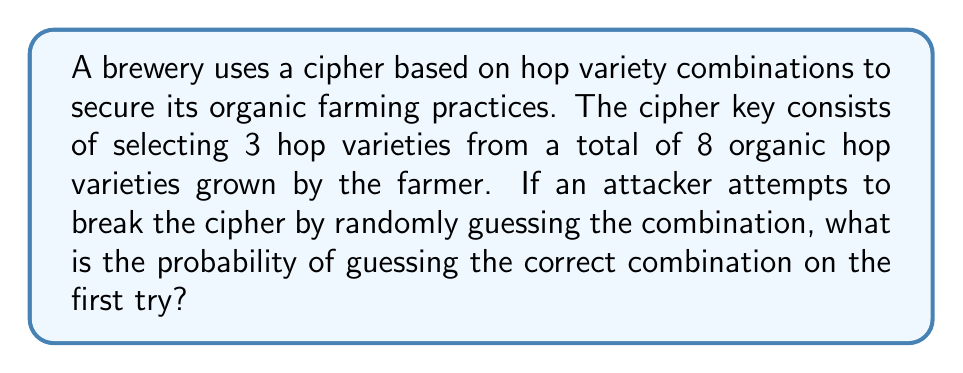Help me with this question. To solve this problem, we need to use the concept of combinations from probability theory.

1. First, we need to calculate the total number of possible combinations:
   - We are selecting 3 hop varieties from 8 total varieties
   - This is a combination problem, as the order doesn't matter
   - We use the combination formula: $C(n,r) = \frac{n!}{r!(n-r)!}$
   - Where $n = 8$ (total varieties) and $r = 3$ (varieties selected)

2. Calculate the number of combinations:
   $$C(8,3) = \frac{8!}{3!(8-3)!} = \frac{8!}{3!5!}$$

3. Expand this:
   $$\frac{8 \cdot 7 \cdot 6 \cdot 5!}{(3 \cdot 2 \cdot 1) \cdot 5!} = \frac{336}{6} = 56$$

4. The probability of guessing correctly on the first try is 1 divided by the total number of possible combinations:
   $$P(\text{correct guess}) = \frac{1}{56}$$

5. This can be simplified to:
   $$P(\text{correct guess}) = \frac{1}{56} \approx 0.0179$$
Answer: $\frac{1}{56}$ 